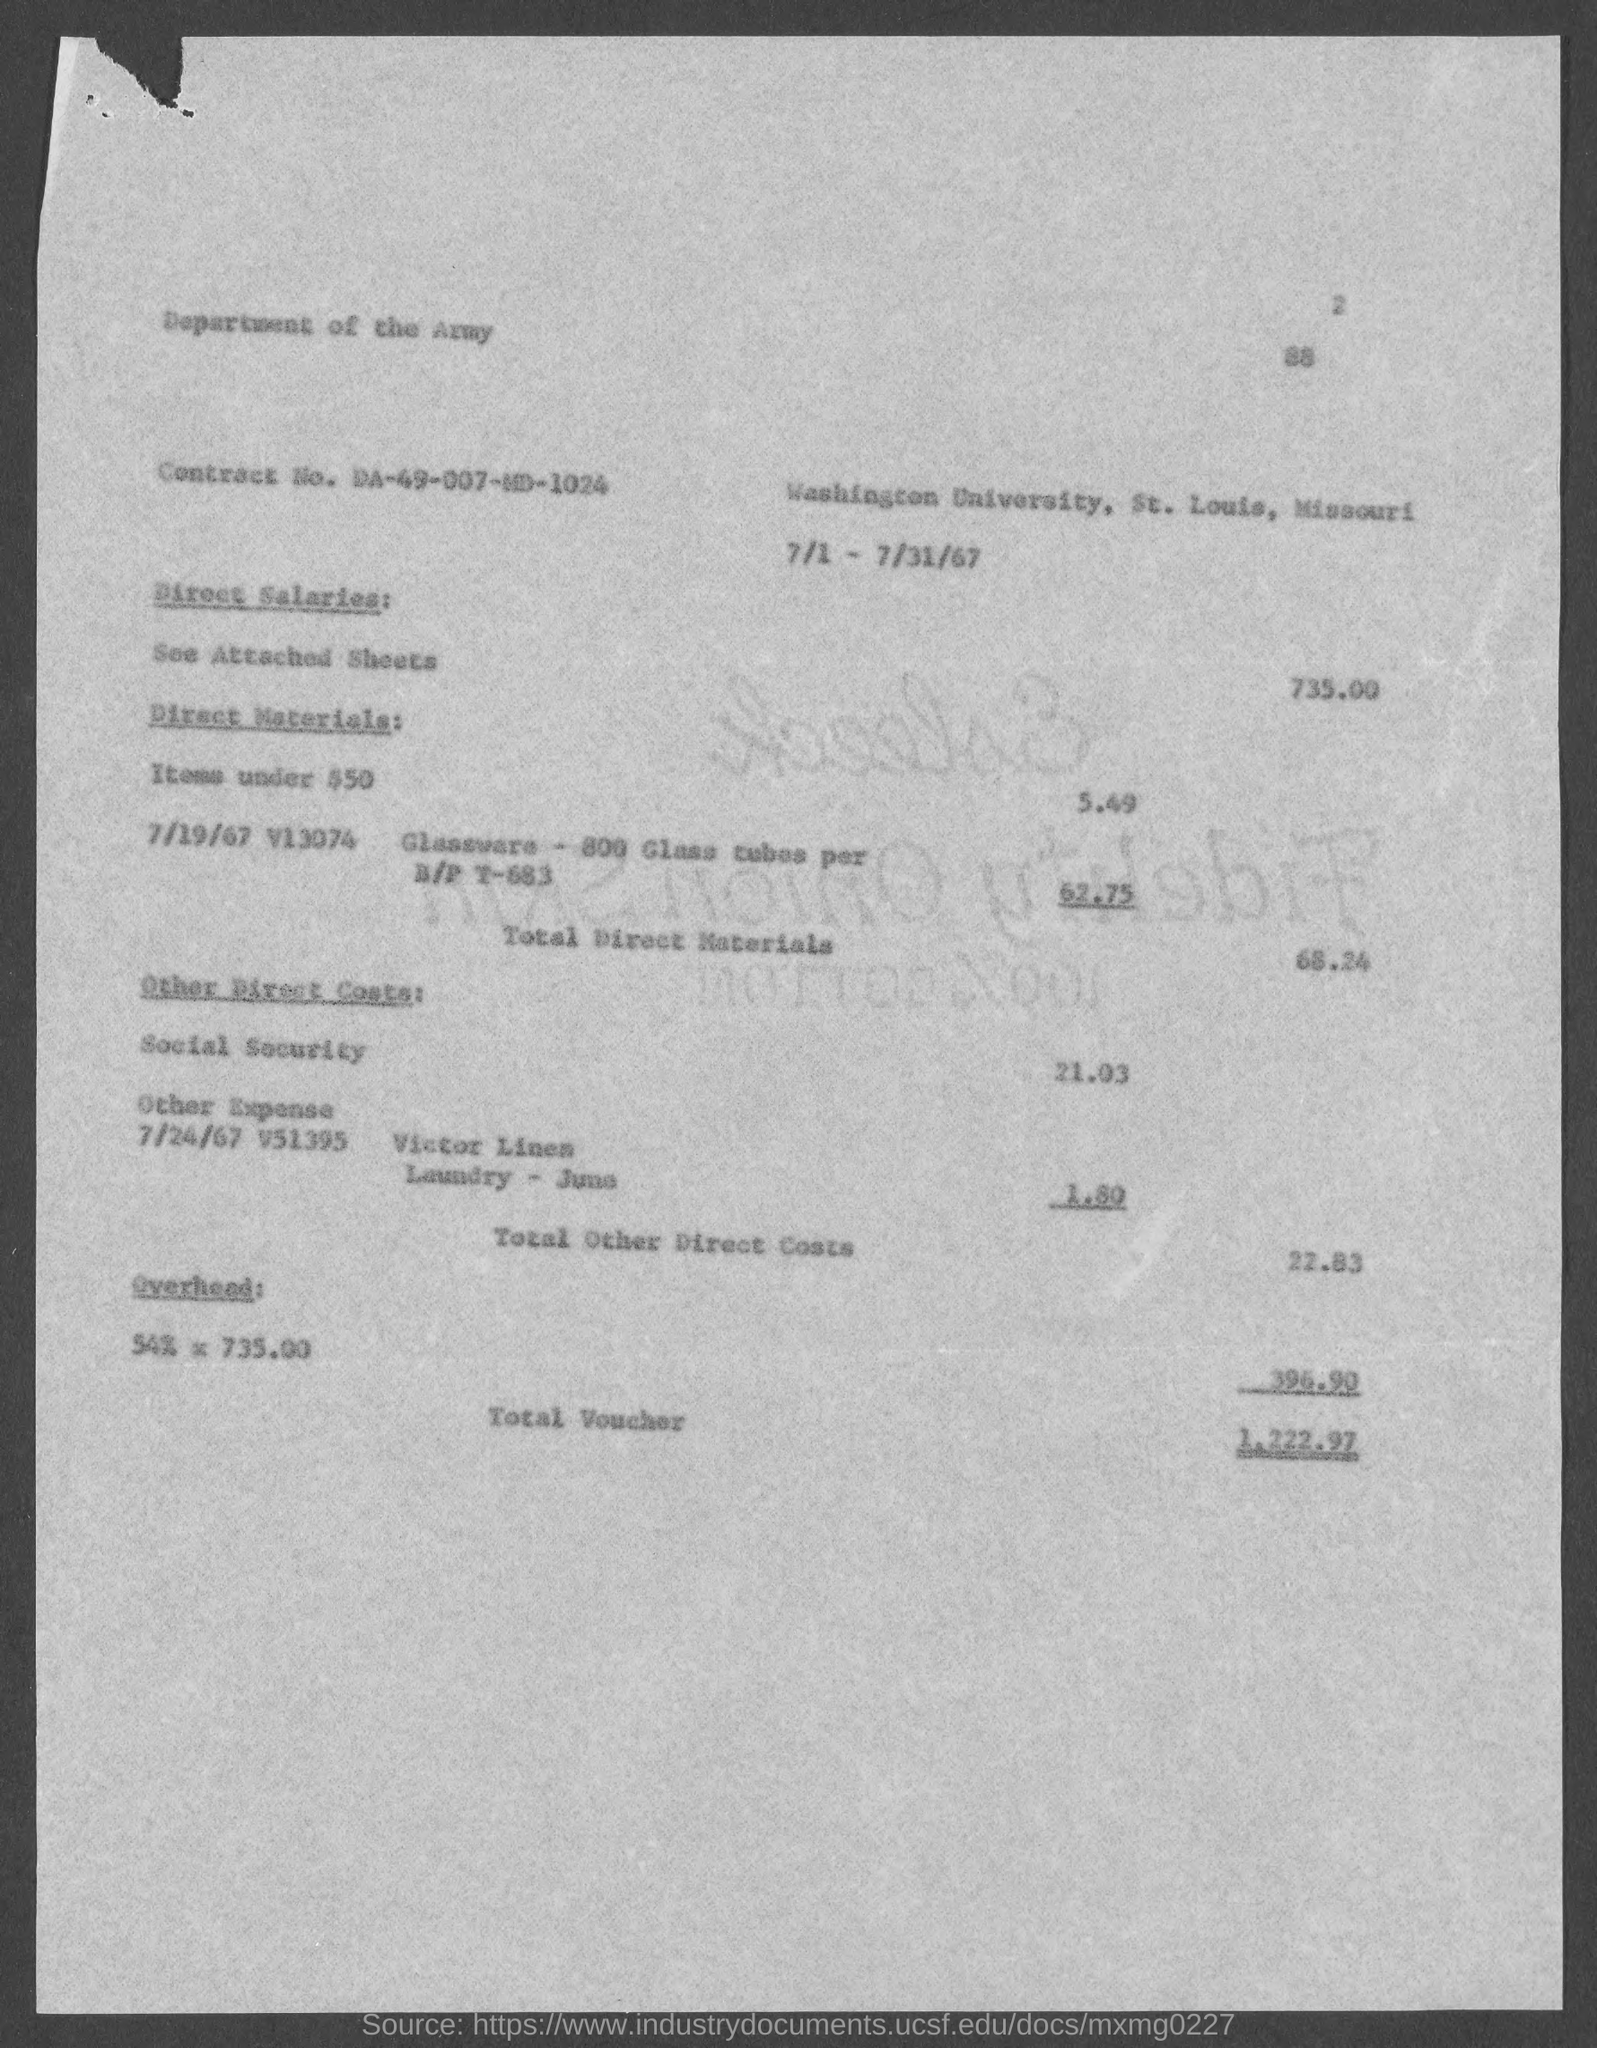What does the Overhead percentage imply about the voucher? The Overhead at a rate of 54% applied to the Direct Salaries of $735.00 implies that there are additional indirect costs associated with administering the project or service. These are not direct expenses like materials or labor, but rather costs that cover support functions, facilities, and administrative roles within the organization that are necessary for the execution of the contracted work. 